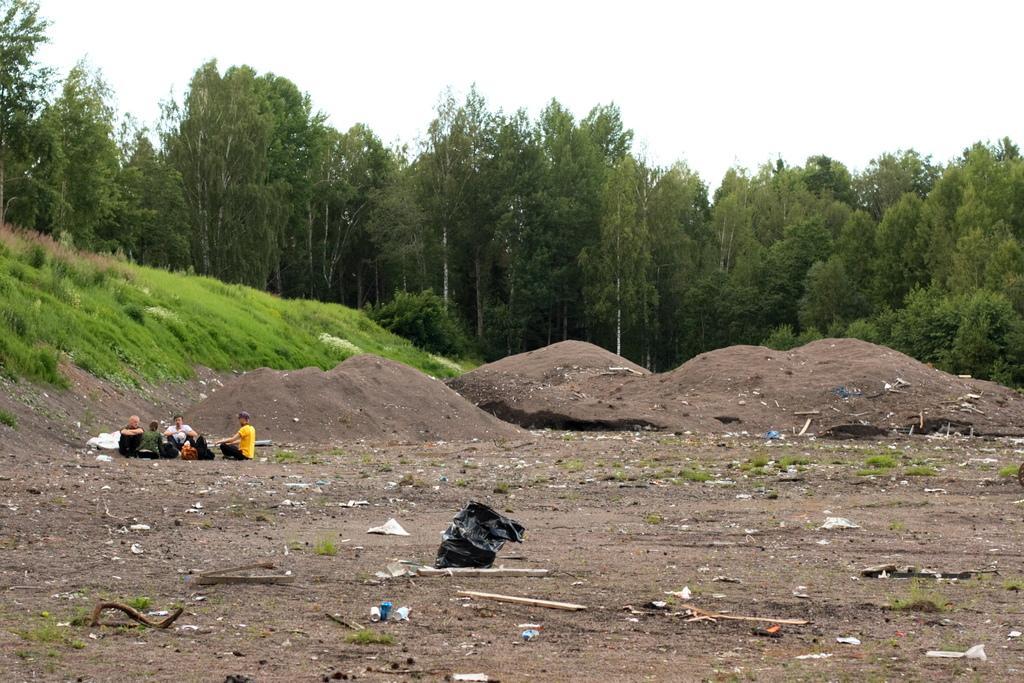Describe this image in one or two sentences. In this image we can see there are a few people sitting on the surface and there are few wooden sticks, plastic covers and some other objects on the surface. In the background there is a grass, trees and a sky. 